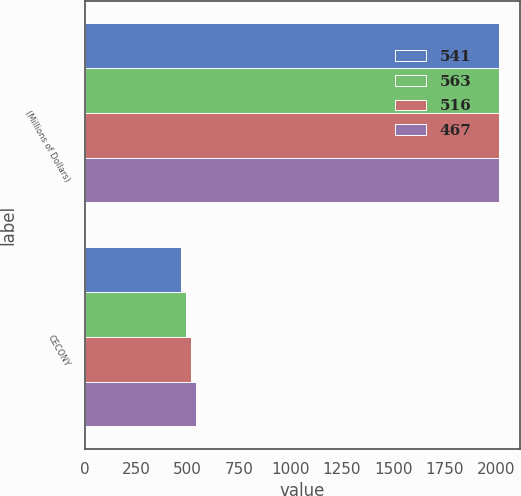Convert chart. <chart><loc_0><loc_0><loc_500><loc_500><stacked_bar_chart><ecel><fcel>(Millions of Dollars)<fcel>CECONY<nl><fcel>541<fcel>2011<fcel>467<nl><fcel>563<fcel>2012<fcel>492<nl><fcel>516<fcel>2013<fcel>516<nl><fcel>467<fcel>2014<fcel>541<nl></chart> 